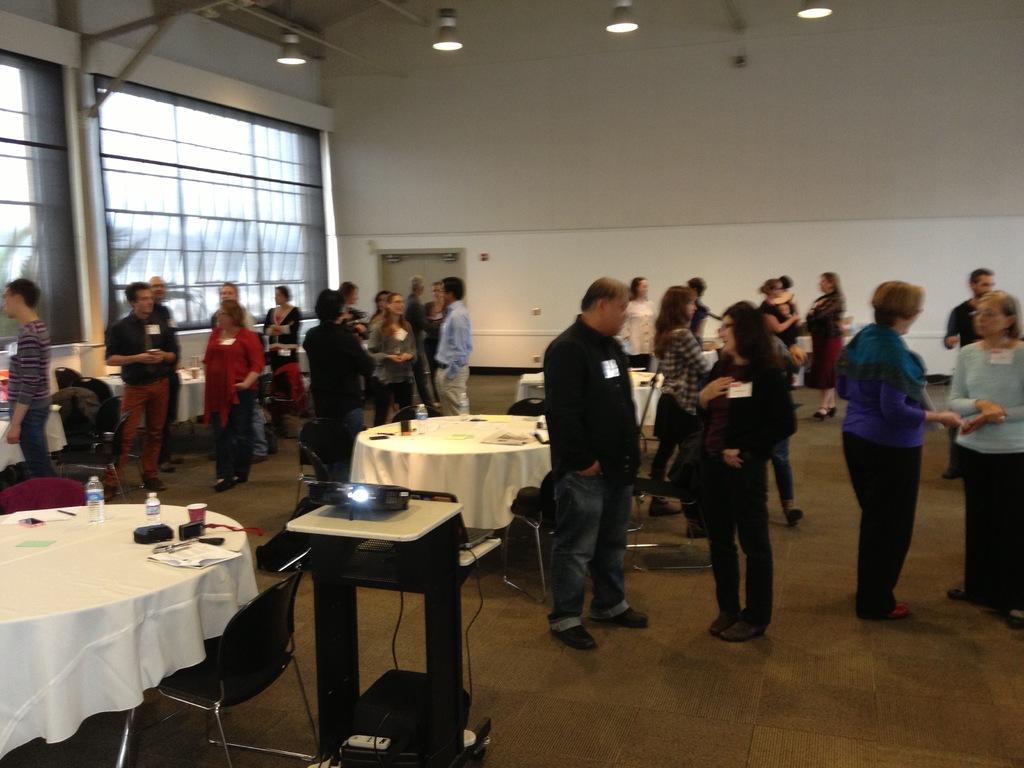Could you give a brief overview of what you see in this image? This picture is clicked inside. On the left there is a projector placed on the top of the table and we can see the chairs and some other objects are placed on the ground and there are some tables on the top of which many number of items are placed we can see the group of persons standing on the ground. In the background we can see the windows, door, wall and the lights hanging on the roof. 